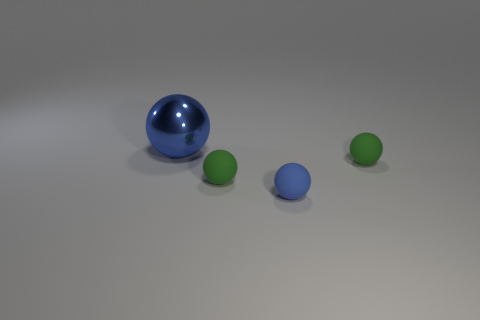Are there any large purple cylinders?
Keep it short and to the point. No. What color is the small thing to the right of the small blue ball?
Your answer should be very brief. Green. How many tiny objects are on the right side of the ball that is to the right of the blue thing that is to the right of the large ball?
Ensure brevity in your answer.  0. The ball that is both to the right of the metallic sphere and on the left side of the blue matte thing is made of what material?
Keep it short and to the point. Rubber. Do the small blue thing and the small green sphere on the left side of the tiny blue rubber object have the same material?
Give a very brief answer. Yes. Is the number of big things to the left of the large ball greater than the number of green things that are in front of the blue matte ball?
Your answer should be very brief. No. What shape is the large object?
Provide a short and direct response. Sphere. Do the blue sphere to the right of the blue shiny thing and the blue thing that is to the left of the tiny blue matte thing have the same material?
Offer a terse response. No. There is a blue object right of the metal ball; what is its shape?
Make the answer very short. Sphere. What size is the other blue object that is the same shape as the big metal object?
Your answer should be very brief. Small. 